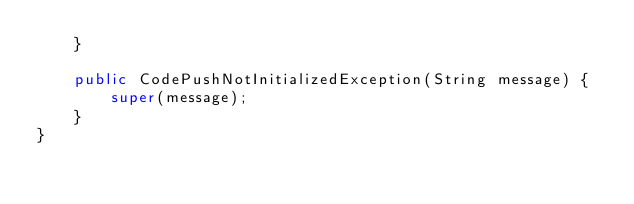<code> <loc_0><loc_0><loc_500><loc_500><_Java_>    }

    public CodePushNotInitializedException(String message) {
        super(message);
    }
}</code> 